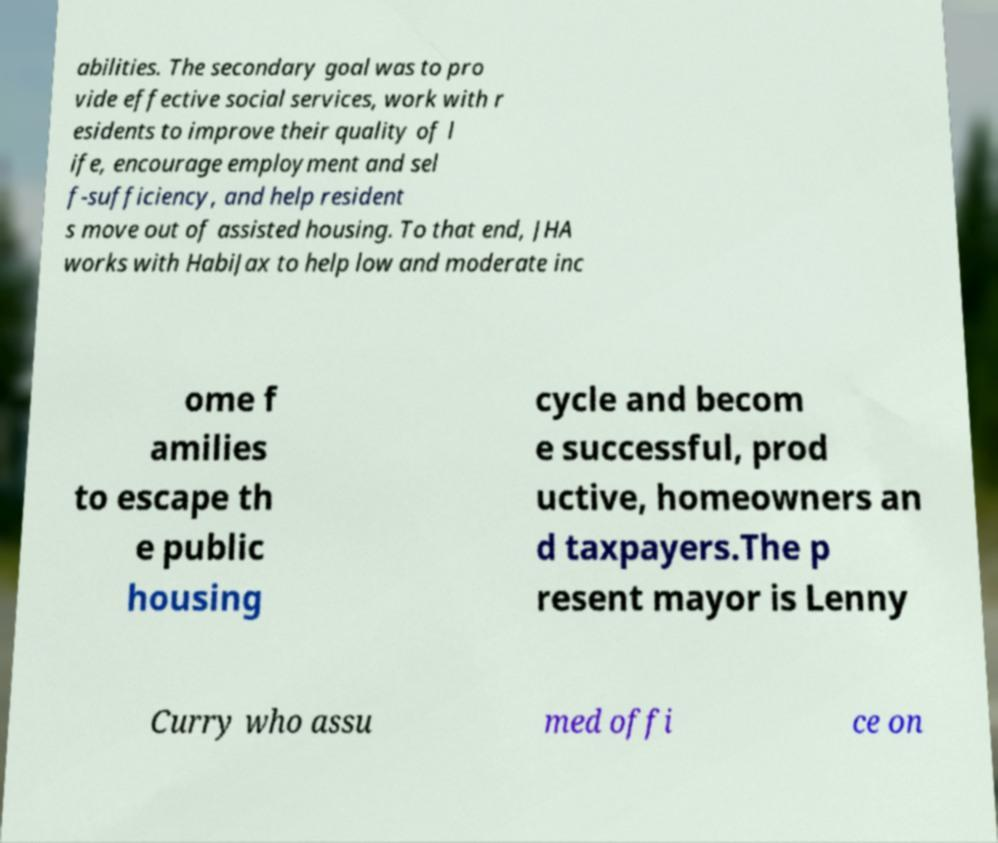I need the written content from this picture converted into text. Can you do that? abilities. The secondary goal was to pro vide effective social services, work with r esidents to improve their quality of l ife, encourage employment and sel f-sufficiency, and help resident s move out of assisted housing. To that end, JHA works with HabiJax to help low and moderate inc ome f amilies to escape th e public housing cycle and becom e successful, prod uctive, homeowners an d taxpayers.The p resent mayor is Lenny Curry who assu med offi ce on 